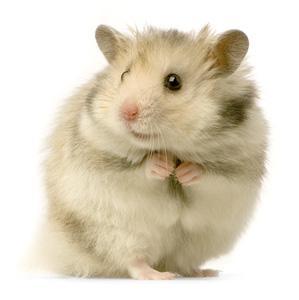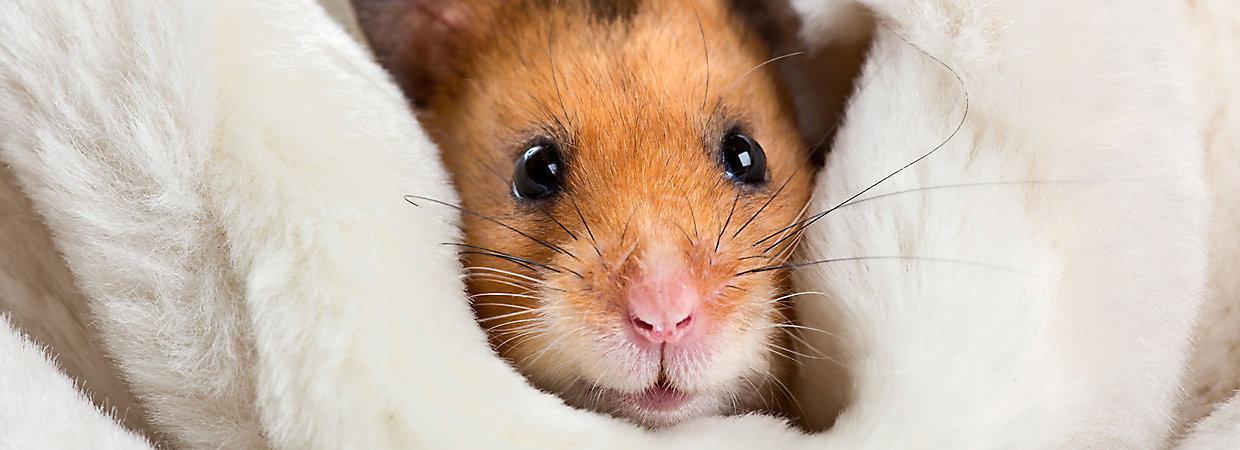The first image is the image on the left, the second image is the image on the right. Considering the images on both sides, is "A hamster is eating a piece of food." valid? Answer yes or no. No. 